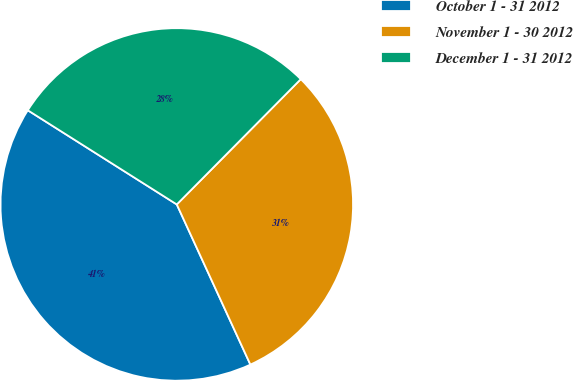Convert chart to OTSL. <chart><loc_0><loc_0><loc_500><loc_500><pie_chart><fcel>October 1 - 31 2012<fcel>November 1 - 30 2012<fcel>December 1 - 31 2012<nl><fcel>40.83%<fcel>30.73%<fcel>28.45%<nl></chart> 